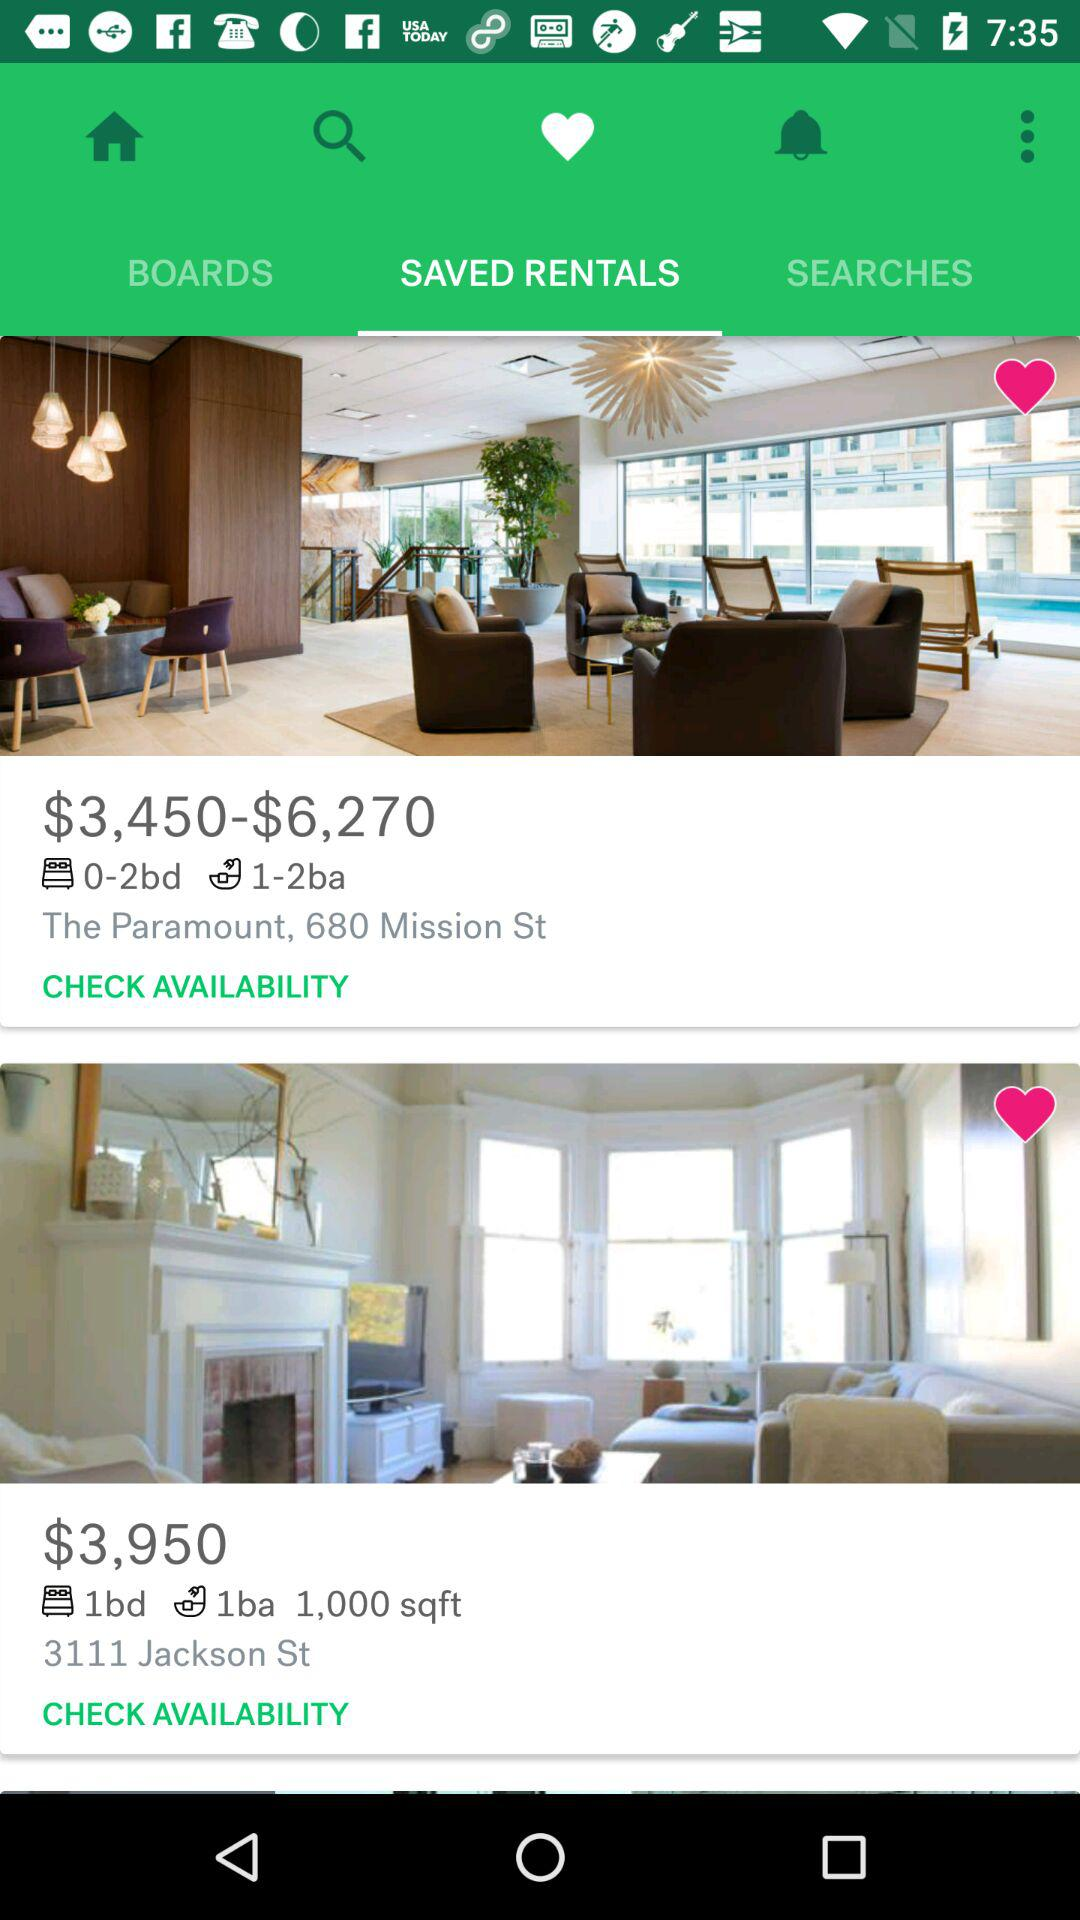What is the currency of the price of rental rooms? The currency is dollars. 